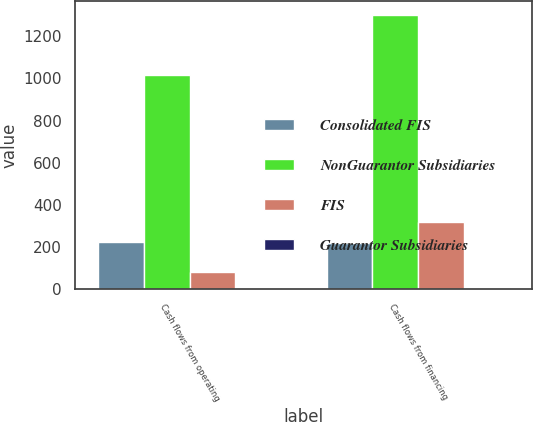Convert chart to OTSL. <chart><loc_0><loc_0><loc_500><loc_500><stacked_bar_chart><ecel><fcel>Cash flows from operating<fcel>Cash flows from financing<nl><fcel>Consolidated FIS<fcel>226.6<fcel>219<nl><fcel>NonGuarantor Subsidiaries<fcel>1014.1<fcel>1300.7<nl><fcel>FIS<fcel>81.9<fcel>320.2<nl><fcel>Guarantor Subsidiaries<fcel>8.5<fcel>8.5<nl></chart> 